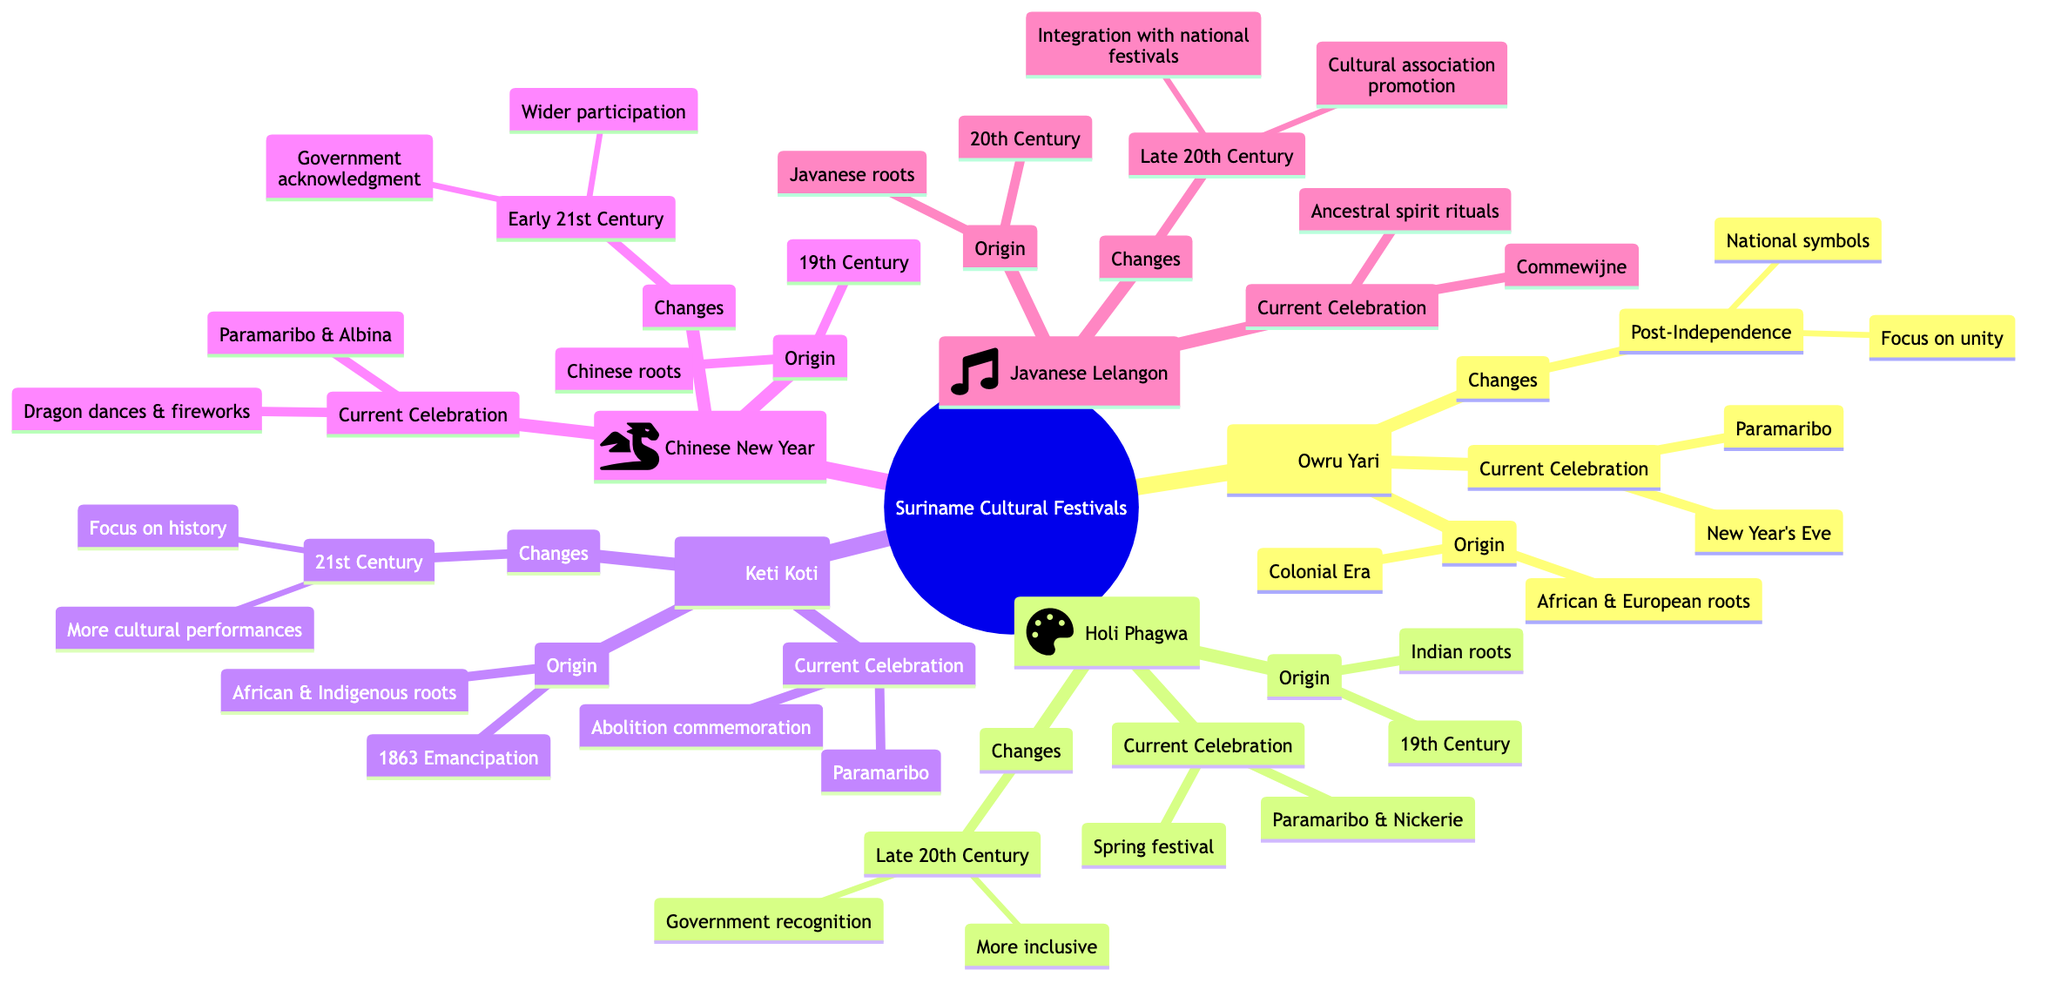What is the period of origin for Owru Yari? The diagram indicates that Owru Yari originated in the Colonial Era.
Answer: Colonial Era What cultural roots are associated with Keti Koti? The diagram shows that Keti Koti has African and Indigenous roots.
Answer: African, Indigenous How many significant changes are noted for Holi Phagwa? The diagram lists two significant changes for Holi Phagwa that occurred in the late 20th century.
Answer: 2 Which festival has its current celebration focused on ancestral spirits? According to the diagram, Javanese Lelangon features current celebrations that focus on ancestral spirits.
Answer: Javanese Lelangon What main location is common to the celebrations of Owru Yari and Keti Koti? The diagram lists Paramaribo as the main location for both Owru Yari and Keti Koti celebrations.
Answer: Paramaribo What were the changes related to the celebration of Chinese New Year in the early 21st century? The diagram specifies that the significant changes for Chinese New Year included wider community participation and government acknowledgment.
Answer: Wider participation, Government acknowledgment Which festival is celebrated with fireworks and dragon dances? The diagram indicates that the Chinese New Year is celebrated with dragon dances and fireworks.
Answer: Chinese New Year In what century did the Javanese Lelangon originate? The diagram indicates that the origin of Javanese Lelangon is in the 20th Century.
Answer: 20th Century 